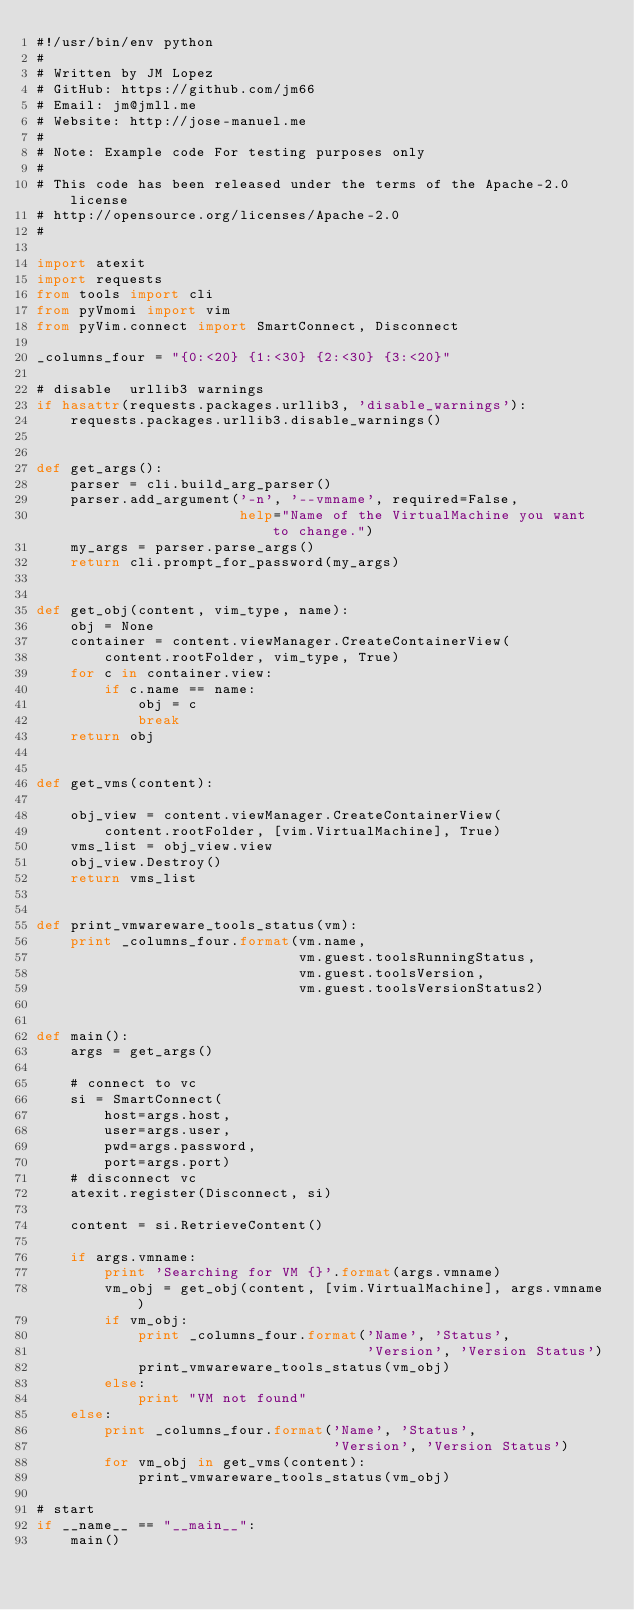<code> <loc_0><loc_0><loc_500><loc_500><_Python_>#!/usr/bin/env python
#
# Written by JM Lopez
# GitHub: https://github.com/jm66
# Email: jm@jmll.me
# Website: http://jose-manuel.me
#
# Note: Example code For testing purposes only
#
# This code has been released under the terms of the Apache-2.0 license
# http://opensource.org/licenses/Apache-2.0
#

import atexit
import requests
from tools import cli
from pyVmomi import vim
from pyVim.connect import SmartConnect, Disconnect

_columns_four = "{0:<20} {1:<30} {2:<30} {3:<20}"

# disable  urllib3 warnings
if hasattr(requests.packages.urllib3, 'disable_warnings'):
    requests.packages.urllib3.disable_warnings()


def get_args():
    parser = cli.build_arg_parser()
    parser.add_argument('-n', '--vmname', required=False,
                        help="Name of the VirtualMachine you want to change.")
    my_args = parser.parse_args()
    return cli.prompt_for_password(my_args)


def get_obj(content, vim_type, name):
    obj = None
    container = content.viewManager.CreateContainerView(
        content.rootFolder, vim_type, True)
    for c in container.view:
        if c.name == name:
            obj = c
            break
    return obj


def get_vms(content):

    obj_view = content.viewManager.CreateContainerView(
        content.rootFolder, [vim.VirtualMachine], True)
    vms_list = obj_view.view
    obj_view.Destroy()
    return vms_list


def print_vmwareware_tools_status(vm):
    print _columns_four.format(vm.name,
                               vm.guest.toolsRunningStatus,
                               vm.guest.toolsVersion,
                               vm.guest.toolsVersionStatus2)


def main():
    args = get_args()

    # connect to vc
    si = SmartConnect(
        host=args.host,
        user=args.user,
        pwd=args.password,
        port=args.port)
    # disconnect vc
    atexit.register(Disconnect, si)

    content = si.RetrieveContent()

    if args.vmname:
        print 'Searching for VM {}'.format(args.vmname)
        vm_obj = get_obj(content, [vim.VirtualMachine], args.vmname)
        if vm_obj:
            print _columns_four.format('Name', 'Status',
                                       'Version', 'Version Status')
            print_vmwareware_tools_status(vm_obj)
        else:
            print "VM not found"
    else:
        print _columns_four.format('Name', 'Status',
                                   'Version', 'Version Status')
        for vm_obj in get_vms(content):
            print_vmwareware_tools_status(vm_obj)

# start
if __name__ == "__main__":
    main()
</code> 